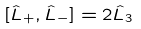<formula> <loc_0><loc_0><loc_500><loc_500>[ { \hat { L } } _ { + } , { \hat { L } } _ { - } ] = 2 { \hat { L } } _ { 3 }</formula> 